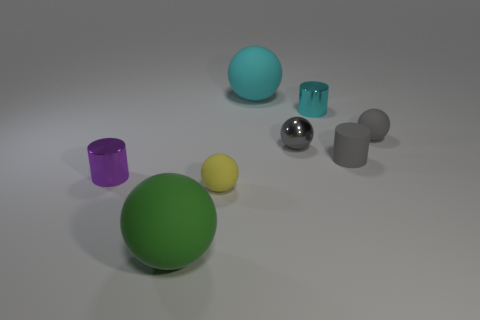There is a small metal object that is the same shape as the large green matte thing; what color is it?
Your answer should be compact. Gray. What number of other objects are the same shape as the large cyan object?
Your answer should be compact. 4. There is a tiny metal cylinder to the left of the tiny yellow object; is its color the same as the tiny metallic sphere?
Your answer should be very brief. No. Are there any other metal balls that have the same color as the metallic sphere?
Your answer should be compact. No. What number of gray objects are on the left side of the cyan metal object?
Keep it short and to the point. 1. What number of other things are the same size as the yellow rubber thing?
Your response must be concise. 5. Is the material of the big object that is right of the tiny yellow sphere the same as the gray ball that is left of the small cyan shiny thing?
Ensure brevity in your answer.  No. The metallic ball that is the same size as the cyan cylinder is what color?
Offer a terse response. Gray. Is there any other thing of the same color as the matte cylinder?
Give a very brief answer. Yes. There is a thing that is in front of the small matte sphere left of the large ball that is behind the purple thing; what is its size?
Make the answer very short. Large. 